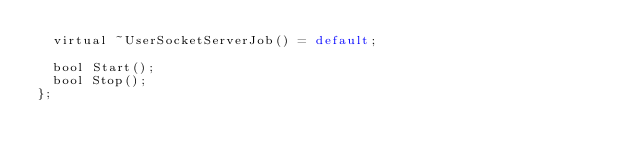<code> <loc_0><loc_0><loc_500><loc_500><_C_>	virtual ~UserSocketServerJob() = default;

	bool Start();
	bool Stop();
};
</code> 